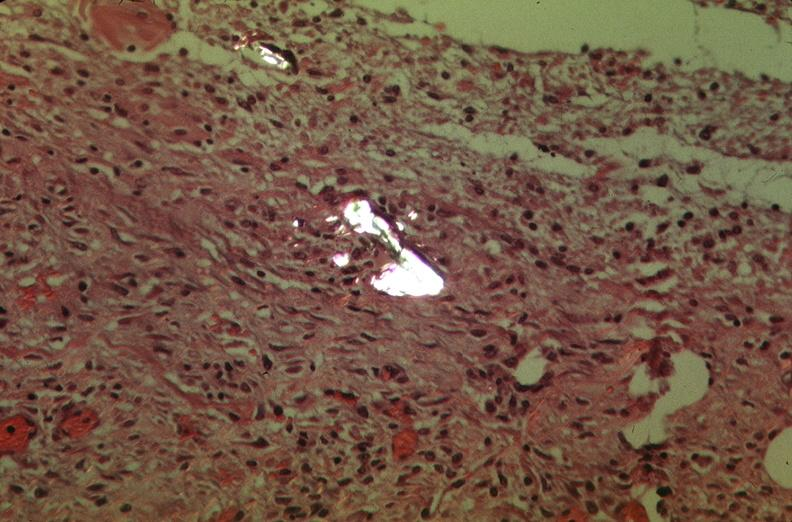where is this?
Answer the question using a single word or phrase. Lung 